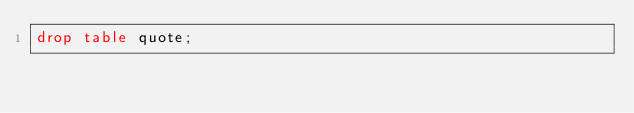Convert code to text. <code><loc_0><loc_0><loc_500><loc_500><_SQL_>drop table quote;</code> 